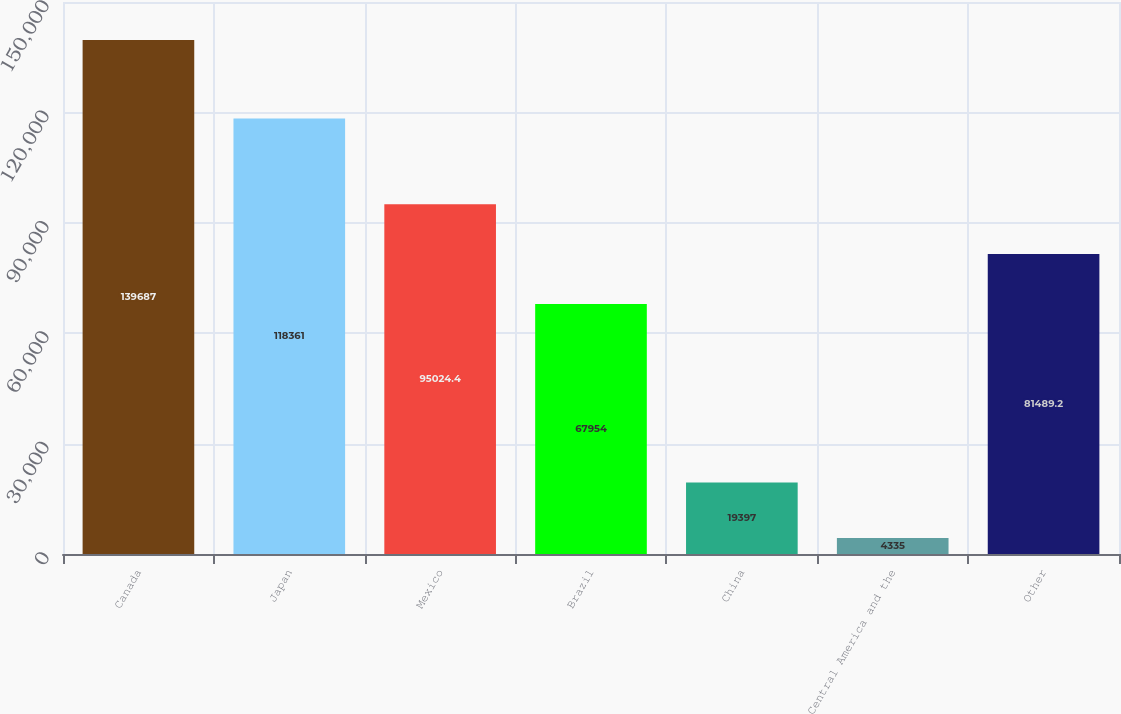Convert chart. <chart><loc_0><loc_0><loc_500><loc_500><bar_chart><fcel>Canada<fcel>Japan<fcel>Mexico<fcel>Brazil<fcel>China<fcel>Central America and the<fcel>Other<nl><fcel>139687<fcel>118361<fcel>95024.4<fcel>67954<fcel>19397<fcel>4335<fcel>81489.2<nl></chart> 